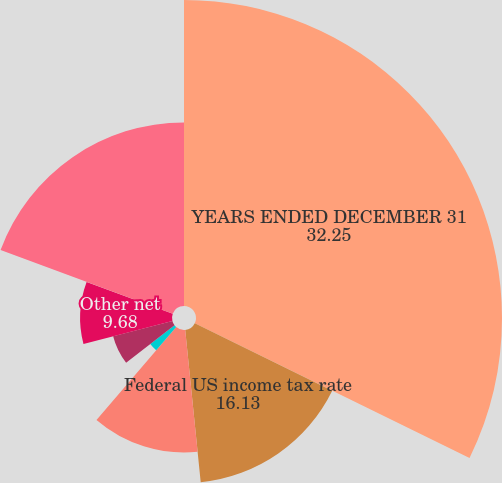<chart> <loc_0><loc_0><loc_500><loc_500><pie_chart><fcel>YEARS ENDED DECEMBER 31<fcel>Federal US income tax rate<fcel>federal tax benefit<fcel>Tax-free interest income<fcel>Non-deductible expenses<fcel>Non-US income taxed at<fcel>Other net<fcel>Effective tax rate<nl><fcel>32.25%<fcel>16.13%<fcel>12.9%<fcel>3.23%<fcel>0.0%<fcel>6.45%<fcel>9.68%<fcel>19.35%<nl></chart> 